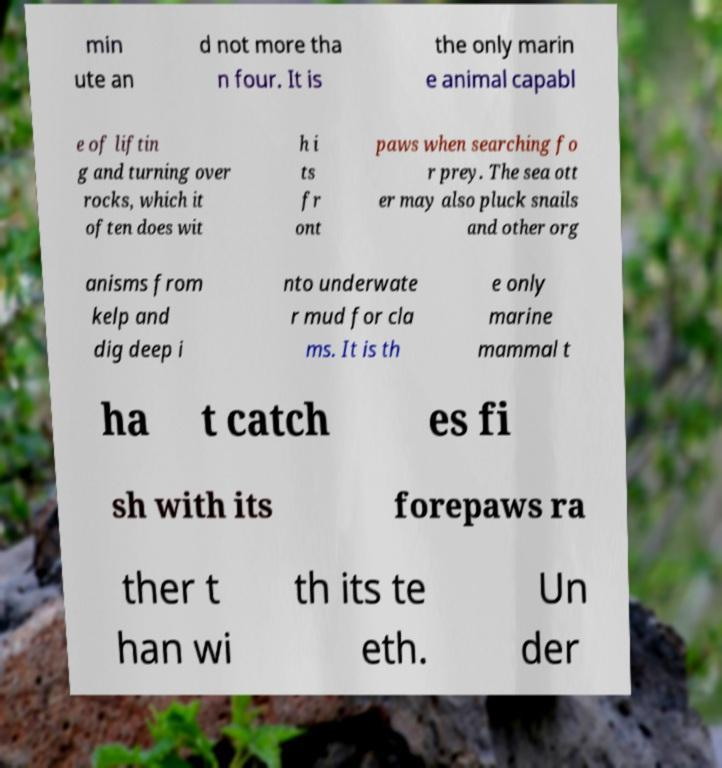Could you assist in decoding the text presented in this image and type it out clearly? min ute an d not more tha n four. It is the only marin e animal capabl e of liftin g and turning over rocks, which it often does wit h i ts fr ont paws when searching fo r prey. The sea ott er may also pluck snails and other org anisms from kelp and dig deep i nto underwate r mud for cla ms. It is th e only marine mammal t ha t catch es fi sh with its forepaws ra ther t han wi th its te eth. Un der 